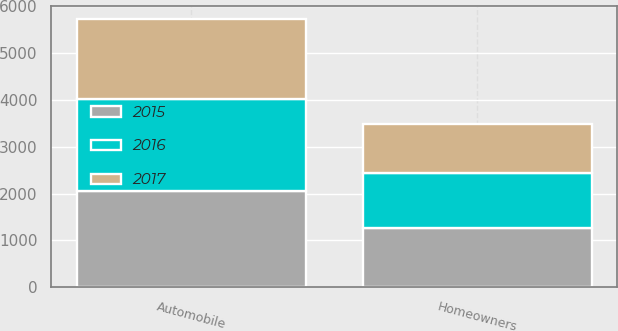Convert chart to OTSL. <chart><loc_0><loc_0><loc_500><loc_500><stacked_bar_chart><ecel><fcel>Automobile<fcel>Homeowners<nl><fcel>2017<fcel>1702<fcel>1038<nl><fcel>2016<fcel>1965<fcel>1176<nl><fcel>2015<fcel>2062<fcel>1272<nl></chart> 